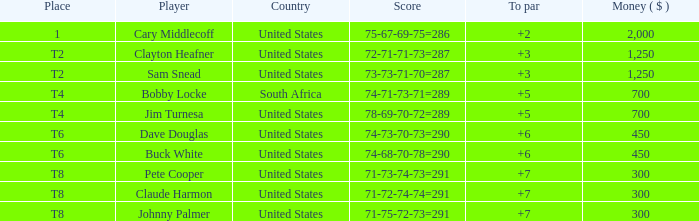What is the johnny palmer with a to greater than 6 money total? 300.0. 